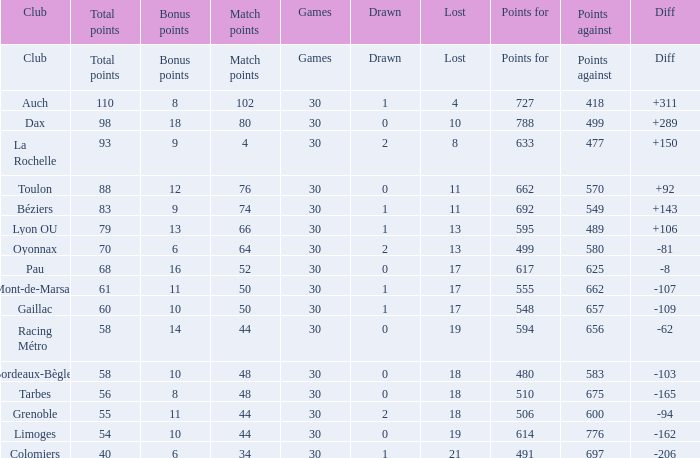What is the variation for a club holding a 662-point value? 92.0. 